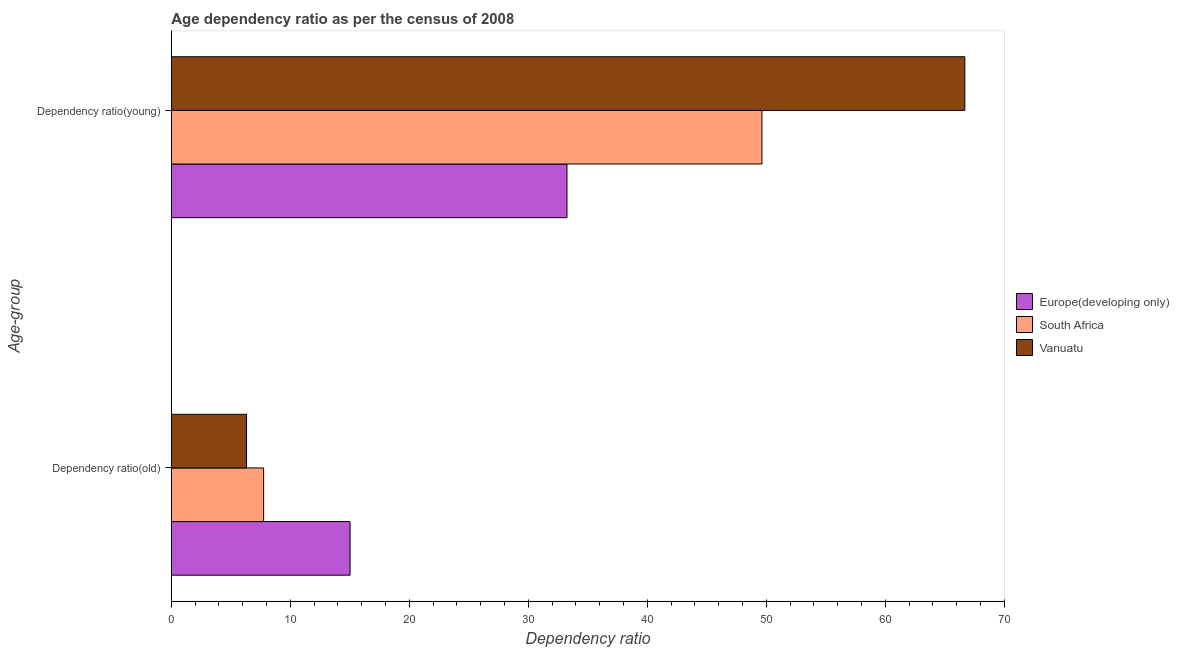How many different coloured bars are there?
Ensure brevity in your answer.  3. Are the number of bars on each tick of the Y-axis equal?
Your answer should be compact. Yes. What is the label of the 2nd group of bars from the top?
Ensure brevity in your answer.  Dependency ratio(old). What is the age dependency ratio(old) in South Africa?
Offer a terse response. 7.75. Across all countries, what is the maximum age dependency ratio(old)?
Offer a very short reply. 15.02. Across all countries, what is the minimum age dependency ratio(old)?
Provide a short and direct response. 6.32. In which country was the age dependency ratio(young) maximum?
Provide a succinct answer. Vanuatu. In which country was the age dependency ratio(old) minimum?
Provide a succinct answer. Vanuatu. What is the total age dependency ratio(old) in the graph?
Your answer should be compact. 29.09. What is the difference between the age dependency ratio(young) in Europe(developing only) and that in Vanuatu?
Ensure brevity in your answer.  -33.44. What is the difference between the age dependency ratio(old) in Vanuatu and the age dependency ratio(young) in South Africa?
Your response must be concise. -43.32. What is the average age dependency ratio(old) per country?
Give a very brief answer. 9.7. What is the difference between the age dependency ratio(young) and age dependency ratio(old) in Vanuatu?
Your answer should be compact. 60.37. What is the ratio of the age dependency ratio(old) in South Africa to that in Vanuatu?
Offer a terse response. 1.23. Is the age dependency ratio(young) in South Africa less than that in Vanuatu?
Offer a very short reply. Yes. In how many countries, is the age dependency ratio(old) greater than the average age dependency ratio(old) taken over all countries?
Your answer should be compact. 1. What does the 2nd bar from the top in Dependency ratio(young) represents?
Ensure brevity in your answer.  South Africa. What does the 1st bar from the bottom in Dependency ratio(young) represents?
Your response must be concise. Europe(developing only). Are all the bars in the graph horizontal?
Offer a terse response. Yes. Are the values on the major ticks of X-axis written in scientific E-notation?
Give a very brief answer. No. Does the graph contain any zero values?
Your answer should be very brief. No. Where does the legend appear in the graph?
Provide a succinct answer. Center right. How many legend labels are there?
Keep it short and to the point. 3. What is the title of the graph?
Offer a terse response. Age dependency ratio as per the census of 2008. What is the label or title of the X-axis?
Offer a very short reply. Dependency ratio. What is the label or title of the Y-axis?
Your response must be concise. Age-group. What is the Dependency ratio in Europe(developing only) in Dependency ratio(old)?
Ensure brevity in your answer.  15.02. What is the Dependency ratio of South Africa in Dependency ratio(old)?
Ensure brevity in your answer.  7.75. What is the Dependency ratio of Vanuatu in Dependency ratio(old)?
Provide a short and direct response. 6.32. What is the Dependency ratio in Europe(developing only) in Dependency ratio(young)?
Offer a very short reply. 33.25. What is the Dependency ratio in South Africa in Dependency ratio(young)?
Offer a very short reply. 49.64. What is the Dependency ratio in Vanuatu in Dependency ratio(young)?
Provide a succinct answer. 66.69. Across all Age-group, what is the maximum Dependency ratio in Europe(developing only)?
Make the answer very short. 33.25. Across all Age-group, what is the maximum Dependency ratio in South Africa?
Offer a terse response. 49.64. Across all Age-group, what is the maximum Dependency ratio of Vanuatu?
Your answer should be compact. 66.69. Across all Age-group, what is the minimum Dependency ratio of Europe(developing only)?
Offer a terse response. 15.02. Across all Age-group, what is the minimum Dependency ratio in South Africa?
Your answer should be compact. 7.75. Across all Age-group, what is the minimum Dependency ratio of Vanuatu?
Your answer should be compact. 6.32. What is the total Dependency ratio in Europe(developing only) in the graph?
Ensure brevity in your answer.  48.27. What is the total Dependency ratio of South Africa in the graph?
Provide a short and direct response. 57.39. What is the total Dependency ratio of Vanuatu in the graph?
Your response must be concise. 73.01. What is the difference between the Dependency ratio of Europe(developing only) in Dependency ratio(old) and that in Dependency ratio(young)?
Make the answer very short. -18.23. What is the difference between the Dependency ratio of South Africa in Dependency ratio(old) and that in Dependency ratio(young)?
Keep it short and to the point. -41.88. What is the difference between the Dependency ratio of Vanuatu in Dependency ratio(old) and that in Dependency ratio(young)?
Provide a succinct answer. -60.37. What is the difference between the Dependency ratio of Europe(developing only) in Dependency ratio(old) and the Dependency ratio of South Africa in Dependency ratio(young)?
Keep it short and to the point. -34.62. What is the difference between the Dependency ratio in Europe(developing only) in Dependency ratio(old) and the Dependency ratio in Vanuatu in Dependency ratio(young)?
Your response must be concise. -51.67. What is the difference between the Dependency ratio in South Africa in Dependency ratio(old) and the Dependency ratio in Vanuatu in Dependency ratio(young)?
Ensure brevity in your answer.  -58.94. What is the average Dependency ratio of Europe(developing only) per Age-group?
Keep it short and to the point. 24.13. What is the average Dependency ratio in South Africa per Age-group?
Ensure brevity in your answer.  28.69. What is the average Dependency ratio in Vanuatu per Age-group?
Keep it short and to the point. 36.5. What is the difference between the Dependency ratio of Europe(developing only) and Dependency ratio of South Africa in Dependency ratio(old)?
Offer a very short reply. 7.26. What is the difference between the Dependency ratio of Europe(developing only) and Dependency ratio of Vanuatu in Dependency ratio(old)?
Provide a succinct answer. 8.7. What is the difference between the Dependency ratio in South Africa and Dependency ratio in Vanuatu in Dependency ratio(old)?
Offer a terse response. 1.44. What is the difference between the Dependency ratio in Europe(developing only) and Dependency ratio in South Africa in Dependency ratio(young)?
Your answer should be compact. -16.39. What is the difference between the Dependency ratio of Europe(developing only) and Dependency ratio of Vanuatu in Dependency ratio(young)?
Offer a very short reply. -33.44. What is the difference between the Dependency ratio of South Africa and Dependency ratio of Vanuatu in Dependency ratio(young)?
Offer a terse response. -17.05. What is the ratio of the Dependency ratio in Europe(developing only) in Dependency ratio(old) to that in Dependency ratio(young)?
Your answer should be compact. 0.45. What is the ratio of the Dependency ratio in South Africa in Dependency ratio(old) to that in Dependency ratio(young)?
Provide a short and direct response. 0.16. What is the ratio of the Dependency ratio in Vanuatu in Dependency ratio(old) to that in Dependency ratio(young)?
Provide a short and direct response. 0.09. What is the difference between the highest and the second highest Dependency ratio in Europe(developing only)?
Offer a very short reply. 18.23. What is the difference between the highest and the second highest Dependency ratio in South Africa?
Offer a very short reply. 41.88. What is the difference between the highest and the second highest Dependency ratio in Vanuatu?
Make the answer very short. 60.37. What is the difference between the highest and the lowest Dependency ratio of Europe(developing only)?
Your response must be concise. 18.23. What is the difference between the highest and the lowest Dependency ratio in South Africa?
Offer a terse response. 41.88. What is the difference between the highest and the lowest Dependency ratio of Vanuatu?
Ensure brevity in your answer.  60.37. 